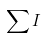<formula> <loc_0><loc_0><loc_500><loc_500>\sum { I }</formula> 